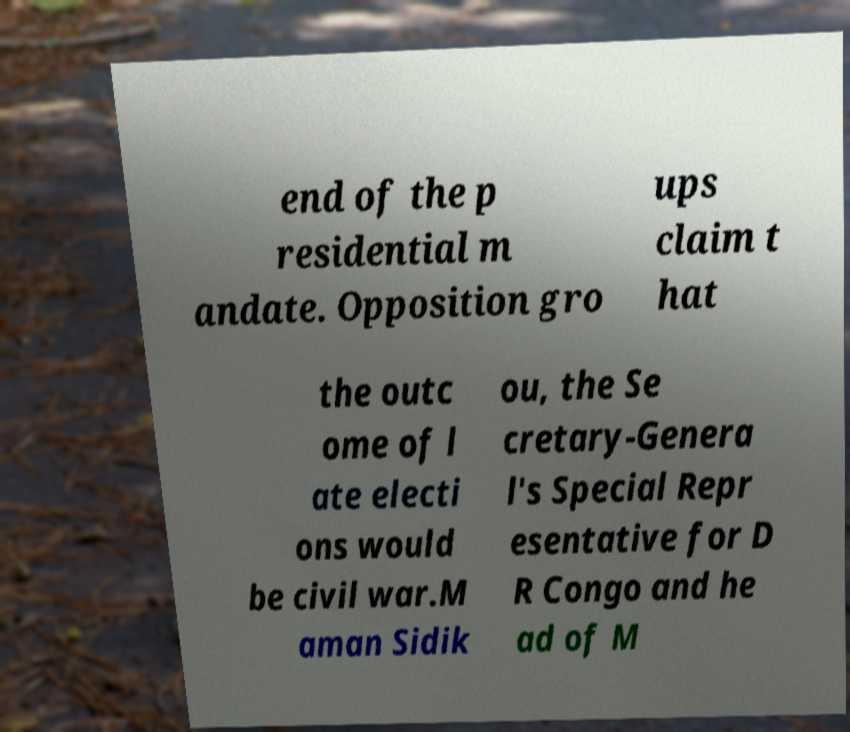Can you read and provide the text displayed in the image?This photo seems to have some interesting text. Can you extract and type it out for me? end of the p residential m andate. Opposition gro ups claim t hat the outc ome of l ate electi ons would be civil war.M aman Sidik ou, the Se cretary-Genera l's Special Repr esentative for D R Congo and he ad of M 